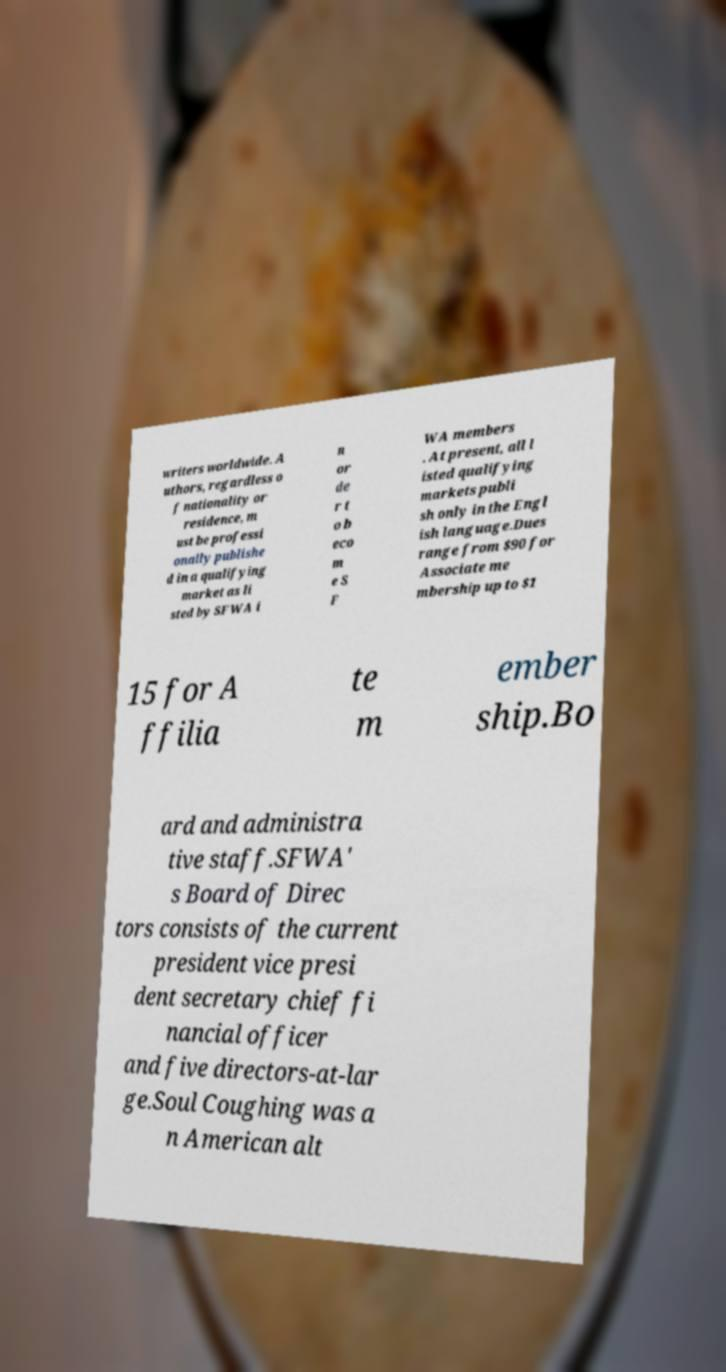Can you read and provide the text displayed in the image?This photo seems to have some interesting text. Can you extract and type it out for me? writers worldwide. A uthors, regardless o f nationality or residence, m ust be professi onally publishe d in a qualifying market as li sted by SFWA i n or de r t o b eco m e S F WA members . At present, all l isted qualifying markets publi sh only in the Engl ish language.Dues range from $90 for Associate me mbership up to $1 15 for A ffilia te m ember ship.Bo ard and administra tive staff.SFWA' s Board of Direc tors consists of the current president vice presi dent secretary chief fi nancial officer and five directors-at-lar ge.Soul Coughing was a n American alt 